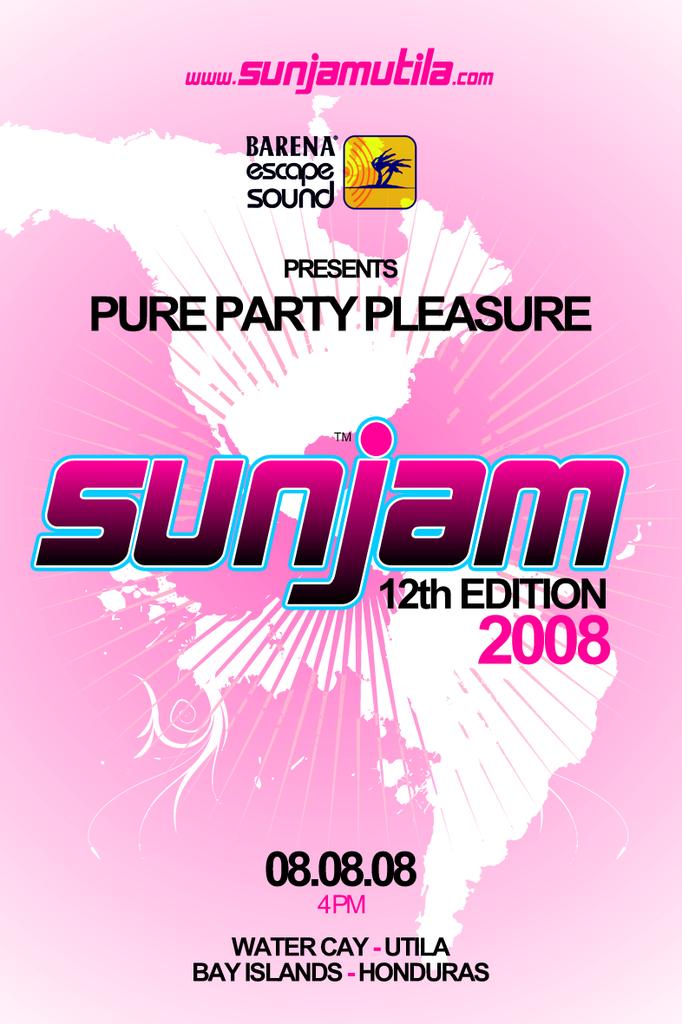What country is this party  being held at?
Your response must be concise. Honduras. What date is the party?
Provide a short and direct response. 08.08.08. 